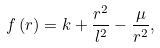<formula> <loc_0><loc_0><loc_500><loc_500>f \left ( r \right ) = k + \frac { r ^ { 2 } } { l ^ { 2 } } - \frac { \mu } { r ^ { 2 } } ,</formula> 